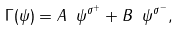<formula> <loc_0><loc_0><loc_500><loc_500>\Gamma ( \psi ) = A \ \psi ^ { \sigma ^ { + } } + B \ \psi ^ { \sigma ^ { - } } ,</formula> 